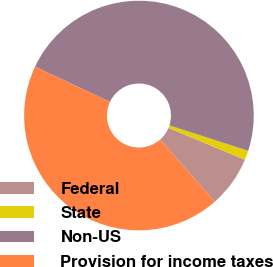Convert chart to OTSL. <chart><loc_0><loc_0><loc_500><loc_500><pie_chart><fcel>Federal<fcel>State<fcel>Non-US<fcel>Provision for income taxes<nl><fcel>7.22%<fcel>1.32%<fcel>47.98%<fcel>43.48%<nl></chart> 